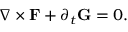<formula> <loc_0><loc_0><loc_500><loc_500>\nabla \times F + \partial _ { t } G = 0 .</formula> 